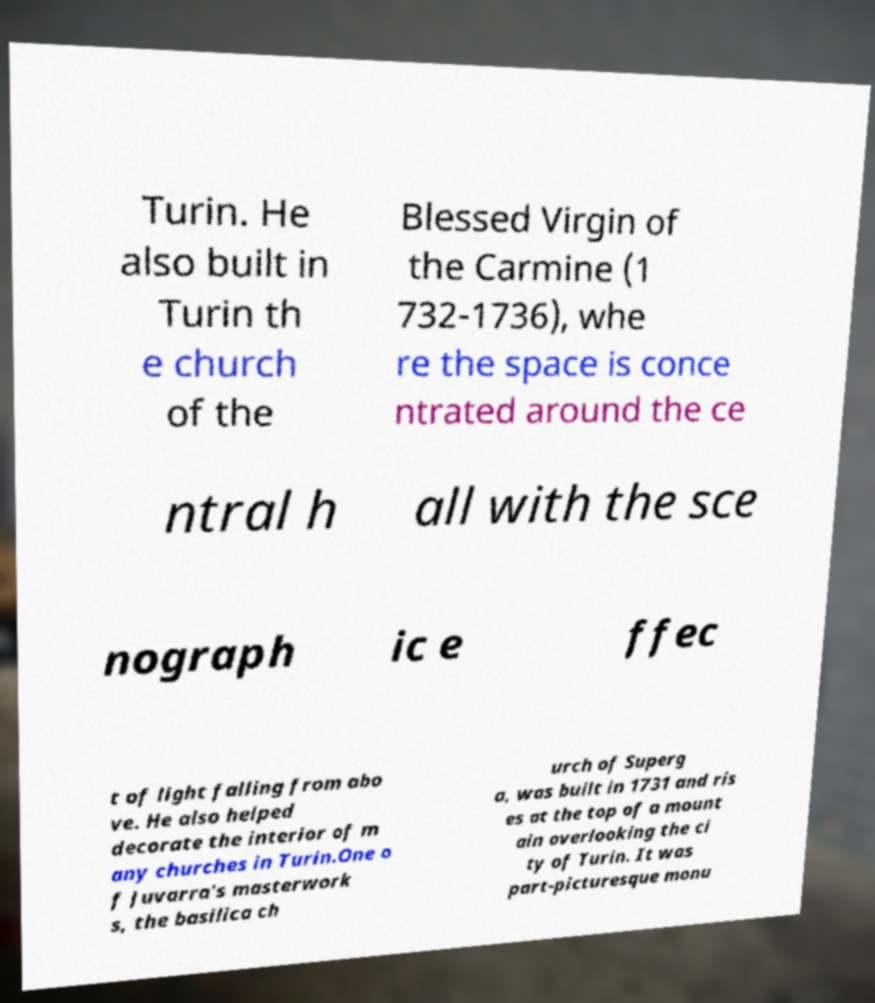Can you accurately transcribe the text from the provided image for me? Turin. He also built in Turin th e church of the Blessed Virgin of the Carmine (1 732-1736), whe re the space is conce ntrated around the ce ntral h all with the sce nograph ic e ffec t of light falling from abo ve. He also helped decorate the interior of m any churches in Turin.One o f Juvarra's masterwork s, the basilica ch urch of Superg a, was built in 1731 and ris es at the top of a mount ain overlooking the ci ty of Turin. It was part-picturesque monu 